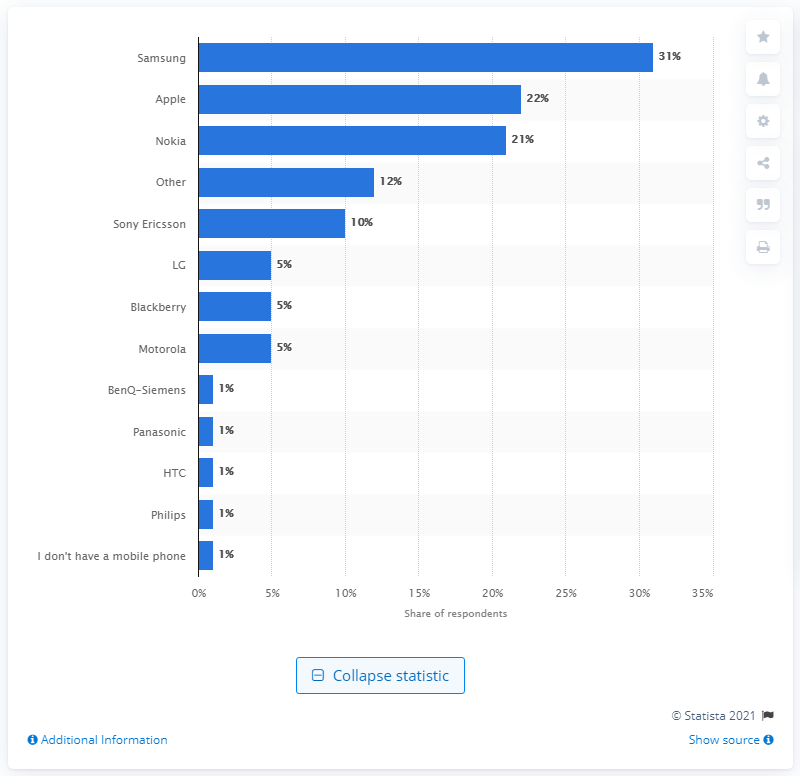Indicate a few pertinent items in this graphic. In 2015, Samsung was the mobile phone brand with the highest market share in the UK. 